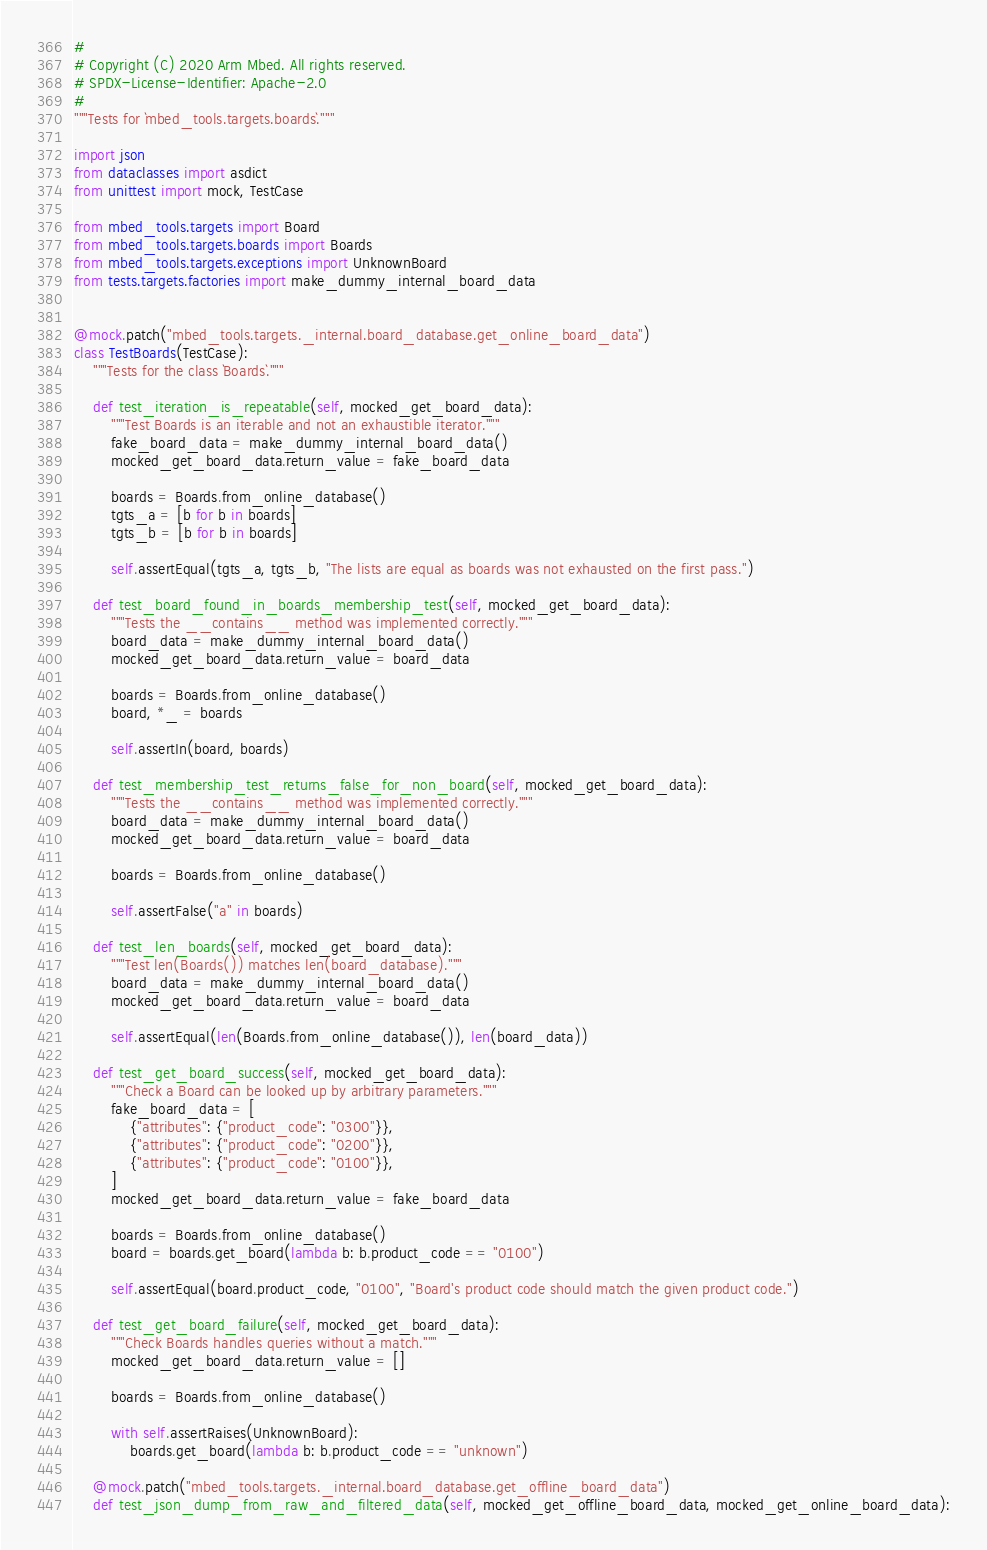<code> <loc_0><loc_0><loc_500><loc_500><_Python_>#
# Copyright (C) 2020 Arm Mbed. All rights reserved.
# SPDX-License-Identifier: Apache-2.0
#
"""Tests for `mbed_tools.targets.boards`."""

import json
from dataclasses import asdict
from unittest import mock, TestCase

from mbed_tools.targets import Board
from mbed_tools.targets.boards import Boards
from mbed_tools.targets.exceptions import UnknownBoard
from tests.targets.factories import make_dummy_internal_board_data


@mock.patch("mbed_tools.targets._internal.board_database.get_online_board_data")
class TestBoards(TestCase):
    """Tests for the class `Boards`."""

    def test_iteration_is_repeatable(self, mocked_get_board_data):
        """Test Boards is an iterable and not an exhaustible iterator."""
        fake_board_data = make_dummy_internal_board_data()
        mocked_get_board_data.return_value = fake_board_data

        boards = Boards.from_online_database()
        tgts_a = [b for b in boards]
        tgts_b = [b for b in boards]

        self.assertEqual(tgts_a, tgts_b, "The lists are equal as boards was not exhausted on the first pass.")

    def test_board_found_in_boards_membership_test(self, mocked_get_board_data):
        """Tests the __contains__ method was implemented correctly."""
        board_data = make_dummy_internal_board_data()
        mocked_get_board_data.return_value = board_data

        boards = Boards.from_online_database()
        board, *_ = boards

        self.assertIn(board, boards)

    def test_membership_test_returns_false_for_non_board(self, mocked_get_board_data):
        """Tests the __contains__ method was implemented correctly."""
        board_data = make_dummy_internal_board_data()
        mocked_get_board_data.return_value = board_data

        boards = Boards.from_online_database()

        self.assertFalse("a" in boards)

    def test_len_boards(self, mocked_get_board_data):
        """Test len(Boards()) matches len(board_database)."""
        board_data = make_dummy_internal_board_data()
        mocked_get_board_data.return_value = board_data

        self.assertEqual(len(Boards.from_online_database()), len(board_data))

    def test_get_board_success(self, mocked_get_board_data):
        """Check a Board can be looked up by arbitrary parameters."""
        fake_board_data = [
            {"attributes": {"product_code": "0300"}},
            {"attributes": {"product_code": "0200"}},
            {"attributes": {"product_code": "0100"}},
        ]
        mocked_get_board_data.return_value = fake_board_data

        boards = Boards.from_online_database()
        board = boards.get_board(lambda b: b.product_code == "0100")

        self.assertEqual(board.product_code, "0100", "Board's product code should match the given product code.")

    def test_get_board_failure(self, mocked_get_board_data):
        """Check Boards handles queries without a match."""
        mocked_get_board_data.return_value = []

        boards = Boards.from_online_database()

        with self.assertRaises(UnknownBoard):
            boards.get_board(lambda b: b.product_code == "unknown")

    @mock.patch("mbed_tools.targets._internal.board_database.get_offline_board_data")
    def test_json_dump_from_raw_and_filtered_data(self, mocked_get_offline_board_data, mocked_get_online_board_data):</code> 